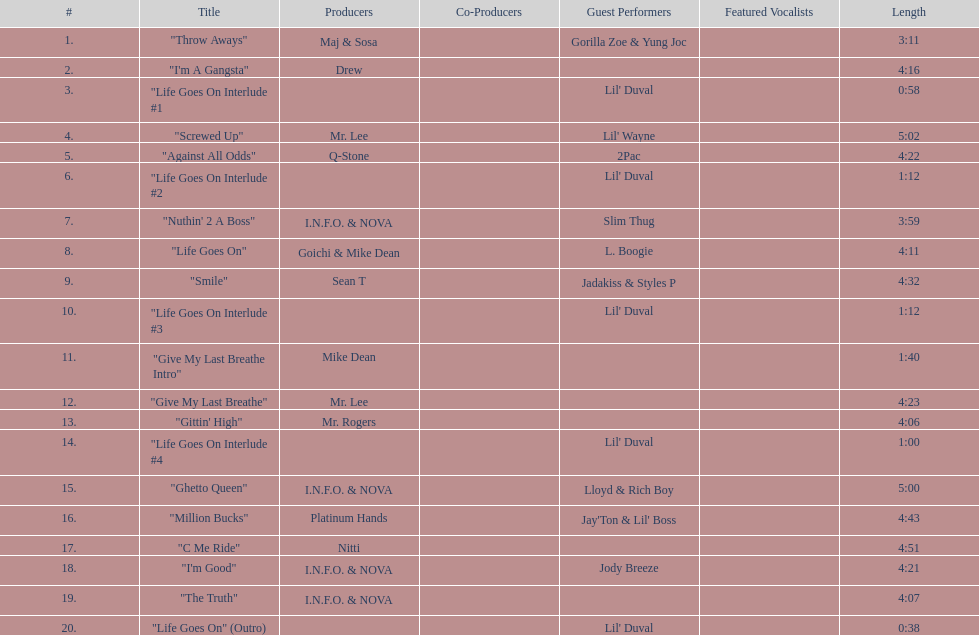What is the longest track on the album? "Screwed Up". 